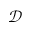Convert formula to latex. <formula><loc_0><loc_0><loc_500><loc_500>\ m a t h s c r { D }</formula> 